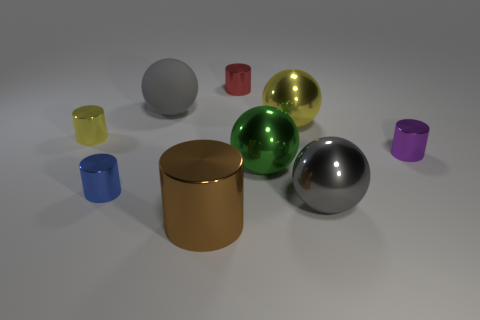What material is the big green sphere?
Make the answer very short. Metal. There is a thing in front of the gray metal object; what material is it?
Provide a short and direct response. Metal. Is there anything else that is made of the same material as the tiny red cylinder?
Ensure brevity in your answer.  Yes. Is the number of small cylinders that are to the right of the small red shiny object greater than the number of large gray rubber cubes?
Make the answer very short. Yes. Is there a large yellow ball behind the yellow metal object that is on the left side of the tiny cylinder in front of the green sphere?
Provide a succinct answer. Yes. There is a tiny blue cylinder; are there any gray metallic spheres behind it?
Provide a short and direct response. No. How many tiny cylinders are the same color as the big rubber ball?
Offer a very short reply. 0. There is a gray sphere that is made of the same material as the small yellow object; what is its size?
Your answer should be very brief. Large. There is a gray ball in front of the large sphere that is behind the yellow metal object that is to the right of the small blue thing; what is its size?
Keep it short and to the point. Large. There is a yellow object on the right side of the rubber object; what is its size?
Offer a terse response. Large. 